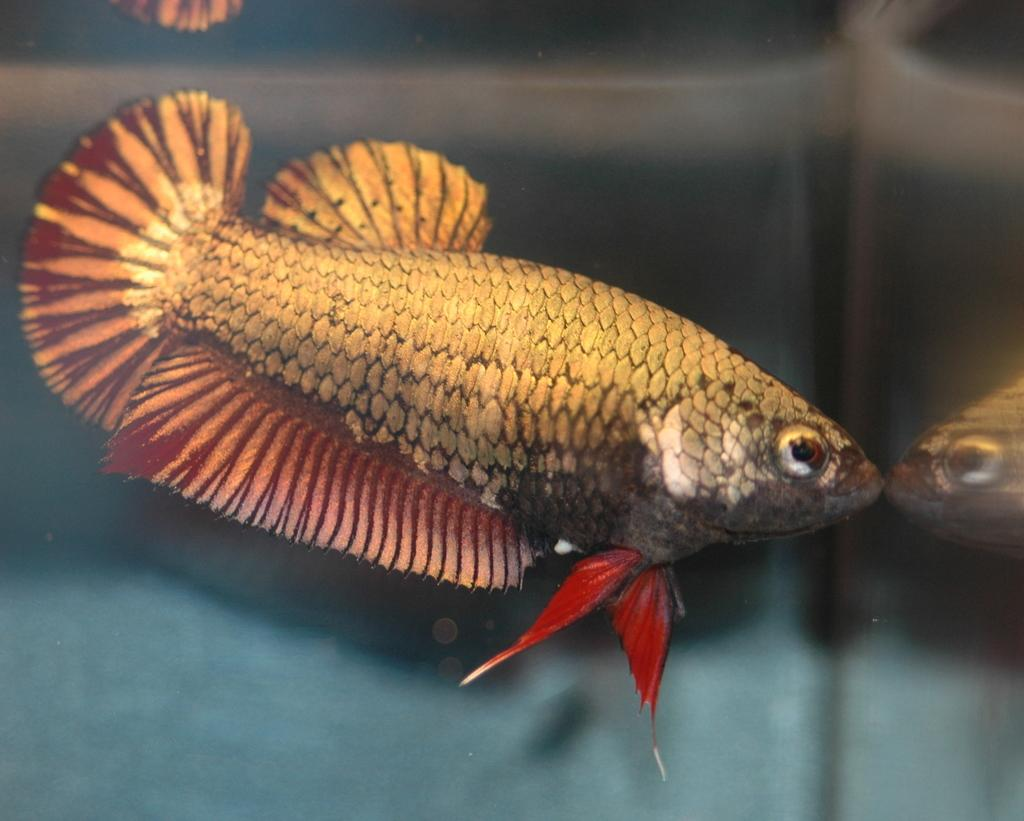What type of animals can be seen in the water? Fish can be seen in the water. What type of knowledge can be gained from the fish ornament in the image? There is no fish ornament present in the image, and therefore no knowledge can be gained from it. 